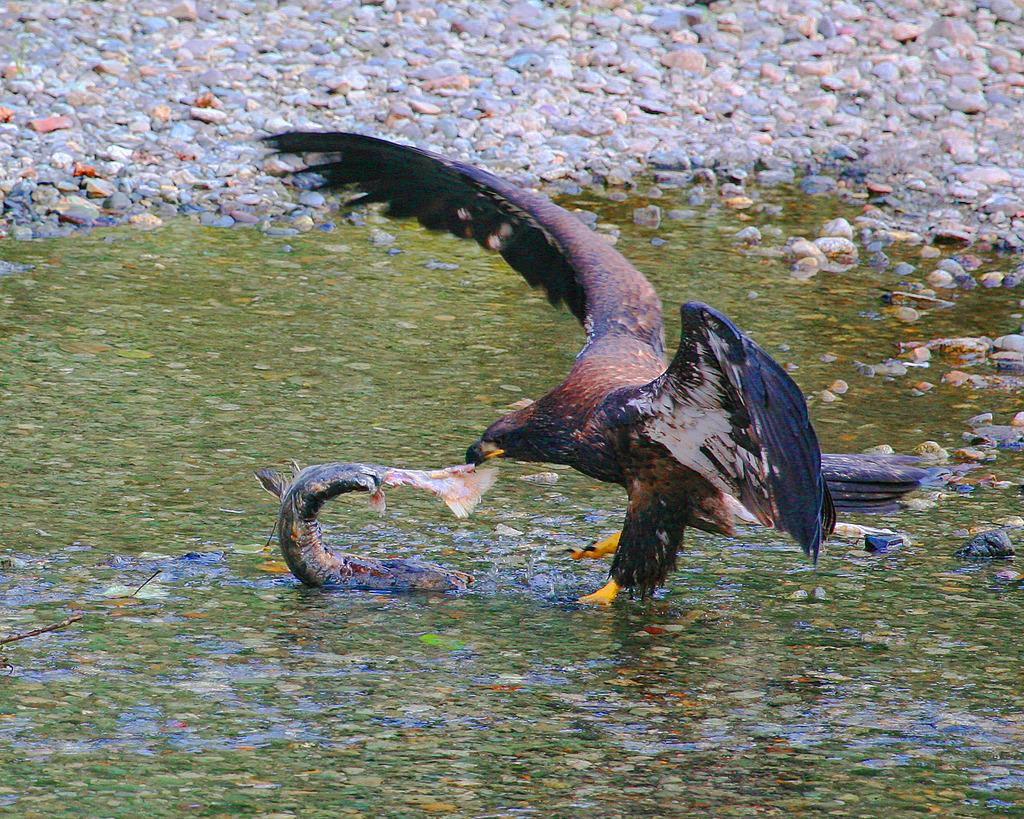What type of animal can be seen in the image? There is an eagle in the image. What is the eagle interacting with in the image? There is a fish in the image, and both the eagle and the fish are on the surface of the water. What can be seen in the background of the image? There are stones visible in the background of the image. What type of fan is visible in the image? There is no fan present in the image. How many visitors can be seen in the image? There are no visitors present in the image. 